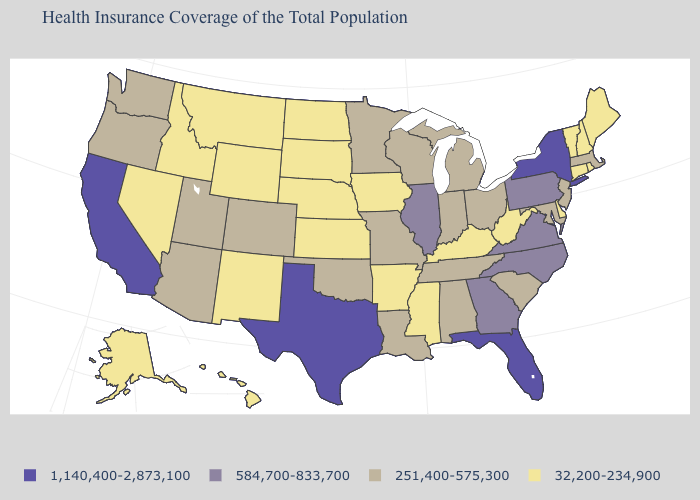What is the value of Idaho?
Quick response, please. 32,200-234,900. Name the states that have a value in the range 32,200-234,900?
Be succinct. Alaska, Arkansas, Connecticut, Delaware, Hawaii, Idaho, Iowa, Kansas, Kentucky, Maine, Mississippi, Montana, Nebraska, Nevada, New Hampshire, New Mexico, North Dakota, Rhode Island, South Dakota, Vermont, West Virginia, Wyoming. Does Maryland have the same value as Michigan?
Answer briefly. Yes. Which states hav the highest value in the West?
Keep it brief. California. Does the map have missing data?
Keep it brief. No. Name the states that have a value in the range 1,140,400-2,873,100?
Short answer required. California, Florida, New York, Texas. Name the states that have a value in the range 584,700-833,700?
Quick response, please. Georgia, Illinois, North Carolina, Pennsylvania, Virginia. What is the value of Missouri?
Keep it brief. 251,400-575,300. Does Iowa have the highest value in the USA?
Short answer required. No. Name the states that have a value in the range 32,200-234,900?
Short answer required. Alaska, Arkansas, Connecticut, Delaware, Hawaii, Idaho, Iowa, Kansas, Kentucky, Maine, Mississippi, Montana, Nebraska, Nevada, New Hampshire, New Mexico, North Dakota, Rhode Island, South Dakota, Vermont, West Virginia, Wyoming. What is the value of Connecticut?
Concise answer only. 32,200-234,900. Among the states that border Florida , which have the lowest value?
Keep it brief. Alabama. How many symbols are there in the legend?
Write a very short answer. 4. What is the value of Arkansas?
Short answer required. 32,200-234,900. What is the highest value in the USA?
Write a very short answer. 1,140,400-2,873,100. 